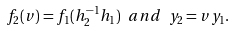Convert formula to latex. <formula><loc_0><loc_0><loc_500><loc_500>f _ { 2 } ( v ) = f _ { 1 } ( h _ { 2 } ^ { - 1 } h _ { 1 } ) \ a n d \ y _ { 2 } = v y _ { 1 } .</formula> 